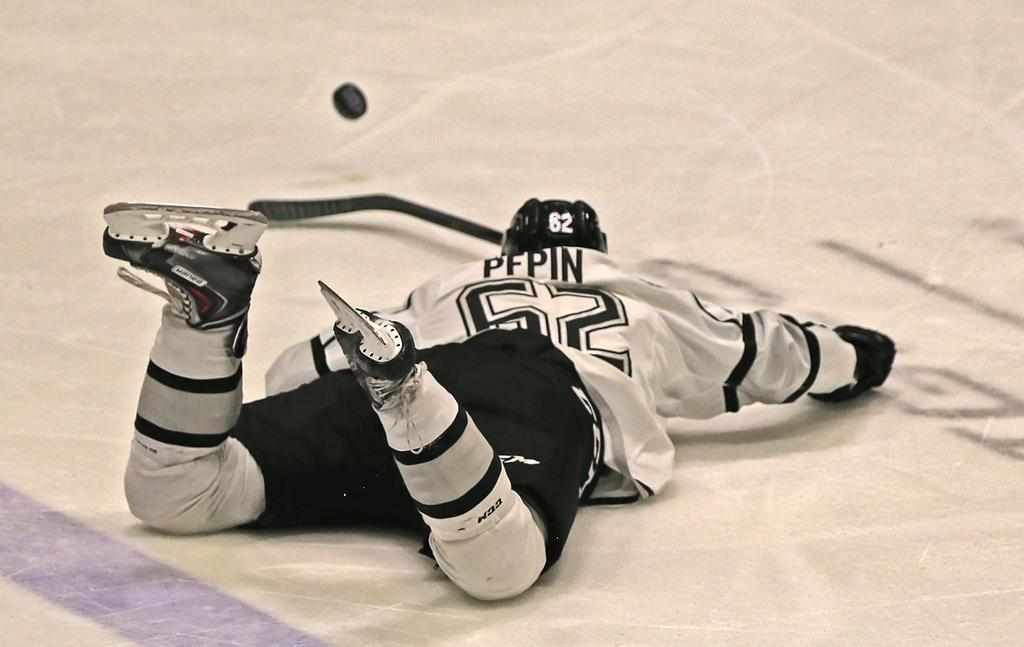<image>
Offer a succinct explanation of the picture presented. Number 62 has fallen flat on his face on the ice. 